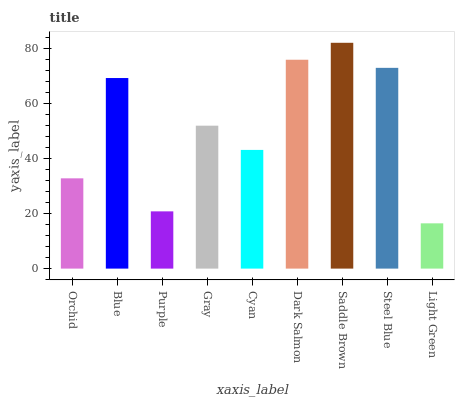Is Light Green the minimum?
Answer yes or no. Yes. Is Saddle Brown the maximum?
Answer yes or no. Yes. Is Blue the minimum?
Answer yes or no. No. Is Blue the maximum?
Answer yes or no. No. Is Blue greater than Orchid?
Answer yes or no. Yes. Is Orchid less than Blue?
Answer yes or no. Yes. Is Orchid greater than Blue?
Answer yes or no. No. Is Blue less than Orchid?
Answer yes or no. No. Is Gray the high median?
Answer yes or no. Yes. Is Gray the low median?
Answer yes or no. Yes. Is Cyan the high median?
Answer yes or no. No. Is Saddle Brown the low median?
Answer yes or no. No. 